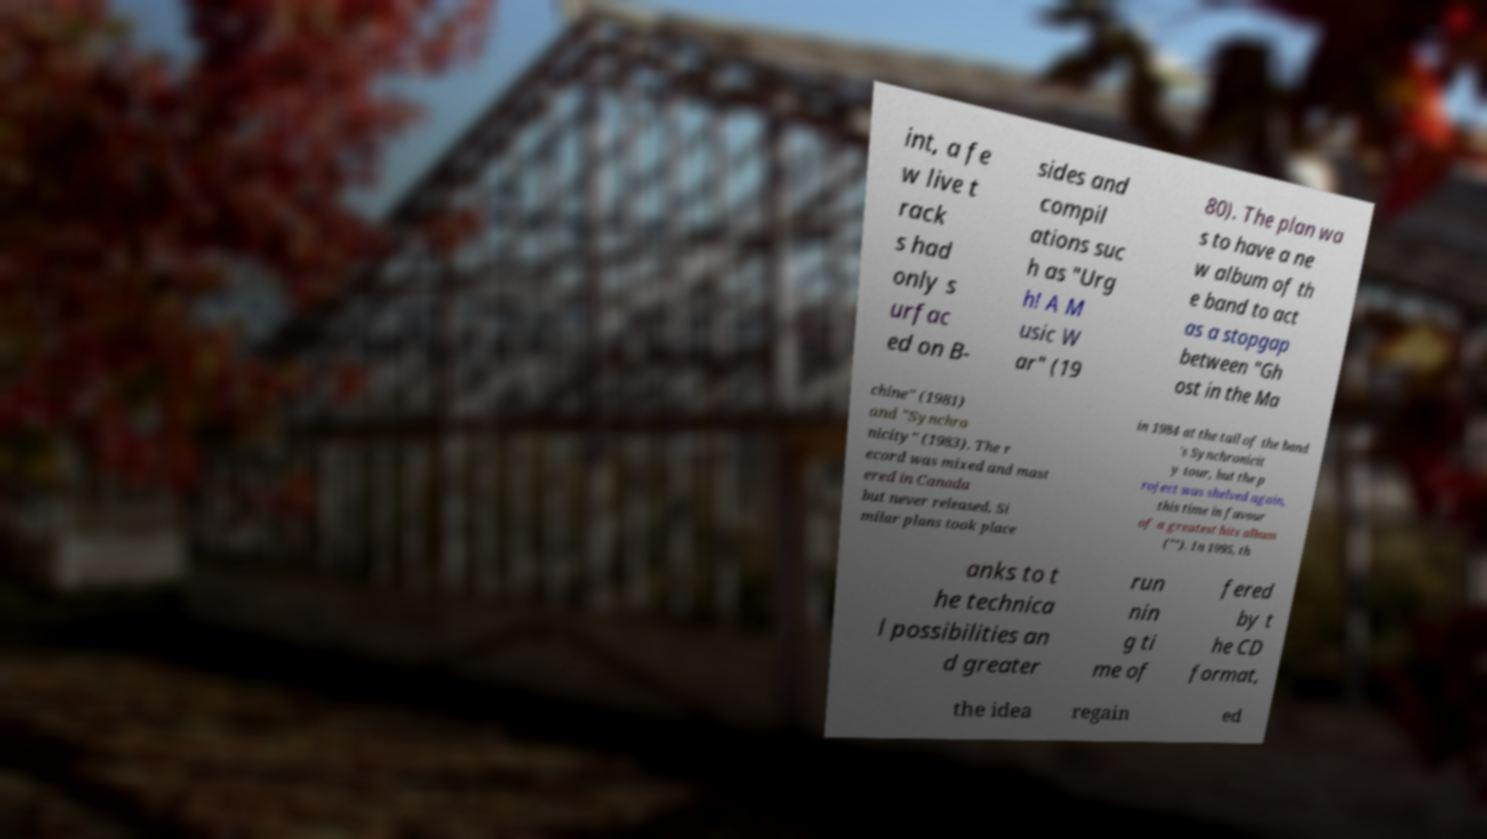Could you assist in decoding the text presented in this image and type it out clearly? int, a fe w live t rack s had only s urfac ed on B- sides and compil ations suc h as "Urg h! A M usic W ar" (19 80). The plan wa s to have a ne w album of th e band to act as a stopgap between "Gh ost in the Ma chine" (1981) and "Synchro nicity" (1983). The r ecord was mixed and mast ered in Canada but never released. Si milar plans took place in 1984 at the tail of the band 's Synchronicit y tour, but the p roject was shelved again, this time in favour of a greatest hits album (""). In 1995, th anks to t he technica l possibilities an d greater run nin g ti me of fered by t he CD format, the idea regain ed 